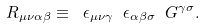<formula> <loc_0><loc_0><loc_500><loc_500>R _ { \mu \nu \alpha \beta } \equiv \ \epsilon _ { \mu \nu \gamma } \ \epsilon _ { \alpha \beta \sigma } \ G ^ { \gamma \sigma } .</formula> 